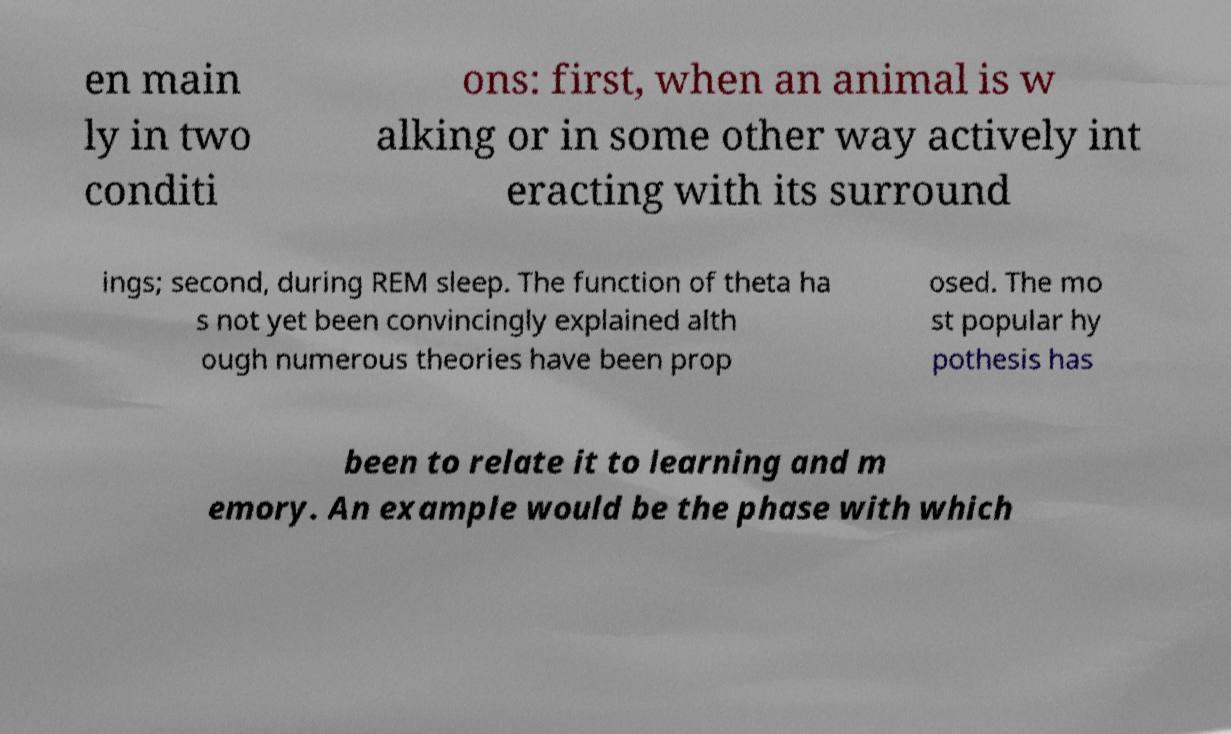Please identify and transcribe the text found in this image. en main ly in two conditi ons: first, when an animal is w alking or in some other way actively int eracting with its surround ings; second, during REM sleep. The function of theta ha s not yet been convincingly explained alth ough numerous theories have been prop osed. The mo st popular hy pothesis has been to relate it to learning and m emory. An example would be the phase with which 